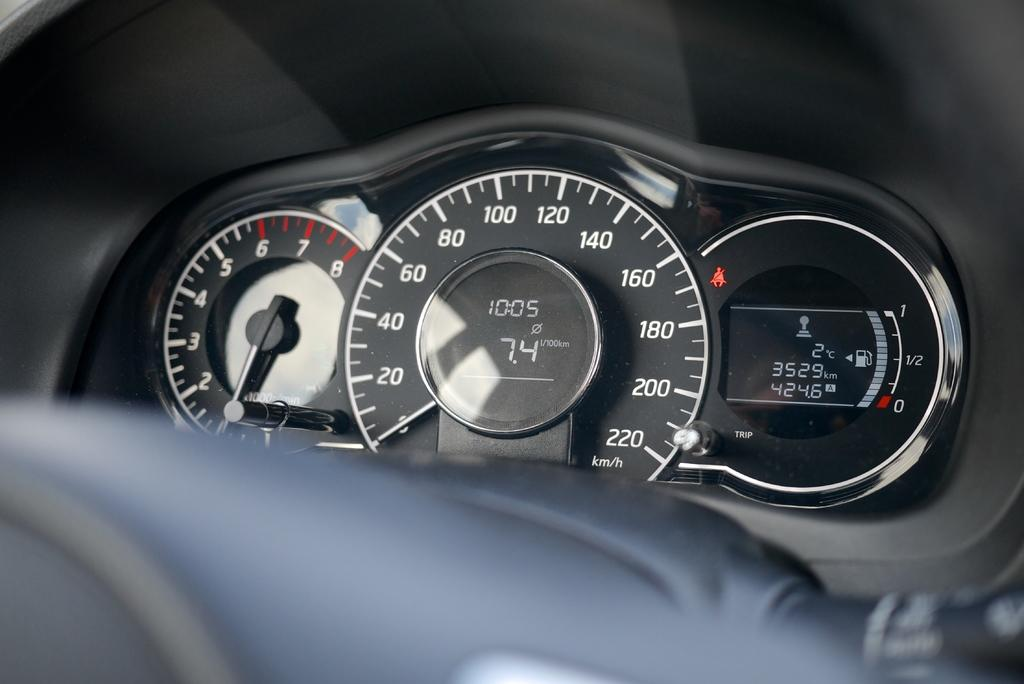What is the main subject of the image? The main subject of the image is speedometers. Can you describe any other objects or features in the image? Unfortunately, the provided facts do not specify any other objects or features in the image. What type of honey can be seen dripping from the cloud in the image? There is no cloud or honey present in the image; it only features speedometers. 